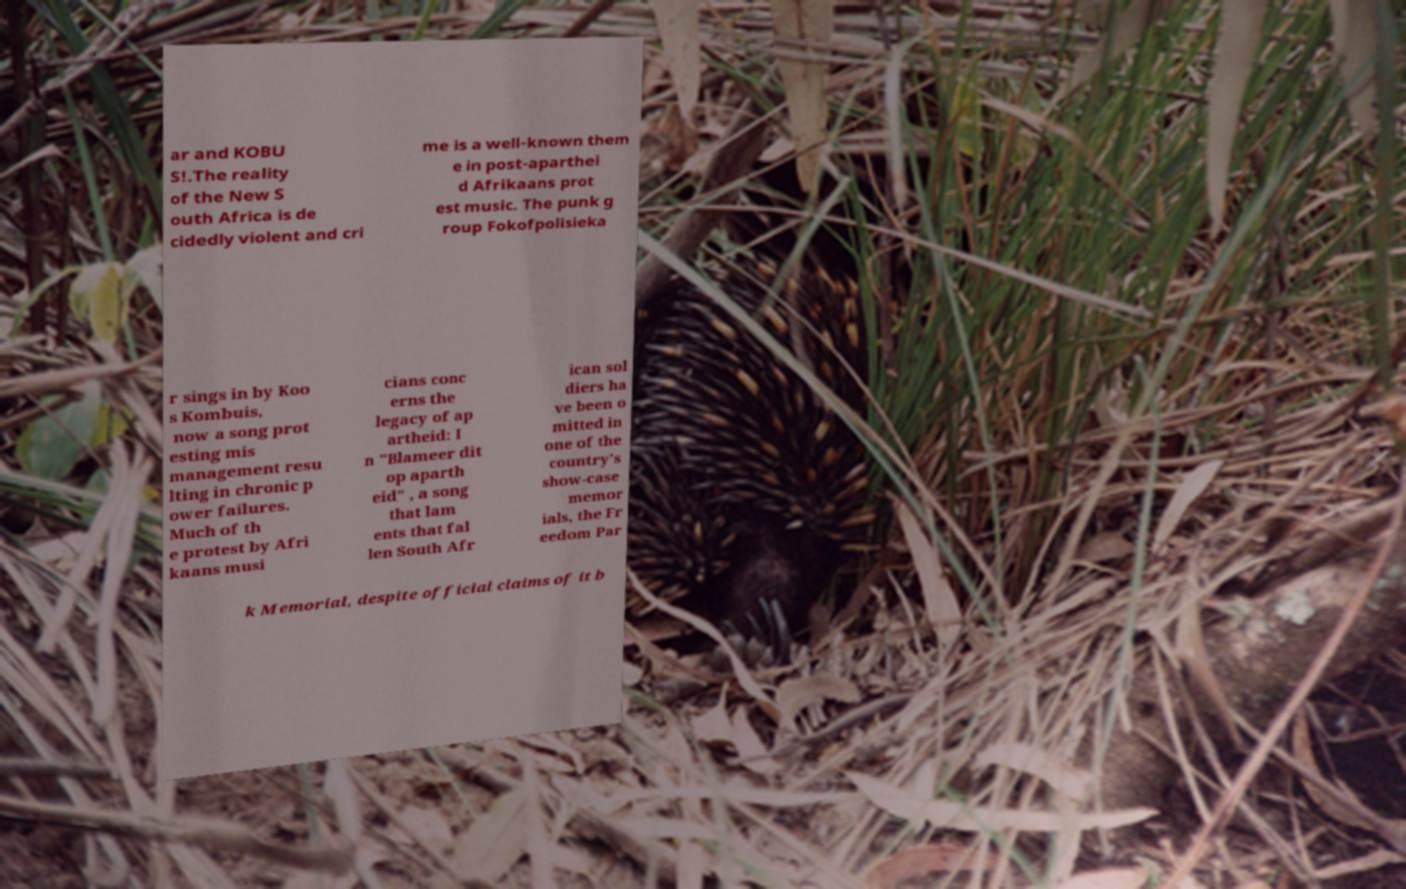For documentation purposes, I need the text within this image transcribed. Could you provide that? ar and KOBU S!.The reality of the New S outh Africa is de cidedly violent and cri me is a well-known them e in post-aparthei d Afrikaans prot est music. The punk g roup Fokofpolisieka r sings in by Koo s Kombuis, now a song prot esting mis management resu lting in chronic p ower failures. Much of th e protest by Afri kaans musi cians conc erns the legacy of ap artheid: I n "Blameer dit op aparth eid" , a song that lam ents that fal len South Afr ican sol diers ha ve been o mitted in one of the country's show-case memor ials, the Fr eedom Par k Memorial, despite official claims of it b 